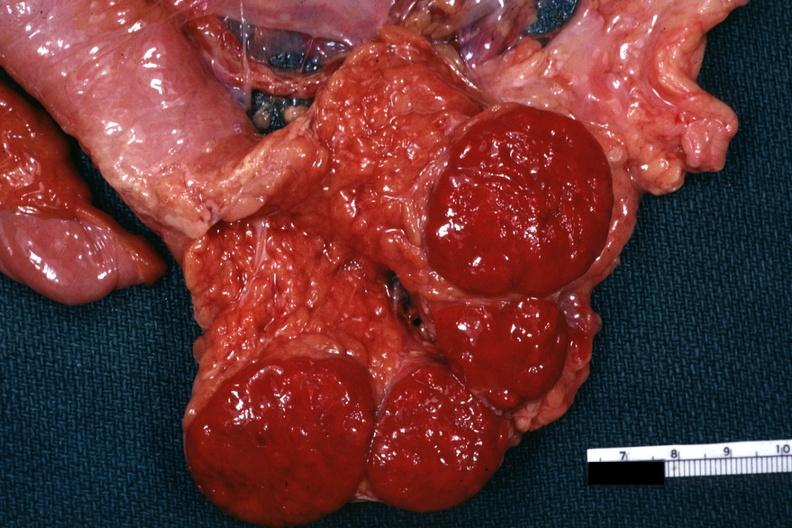where is this part in?
Answer the question using a single word or phrase. Spleen 